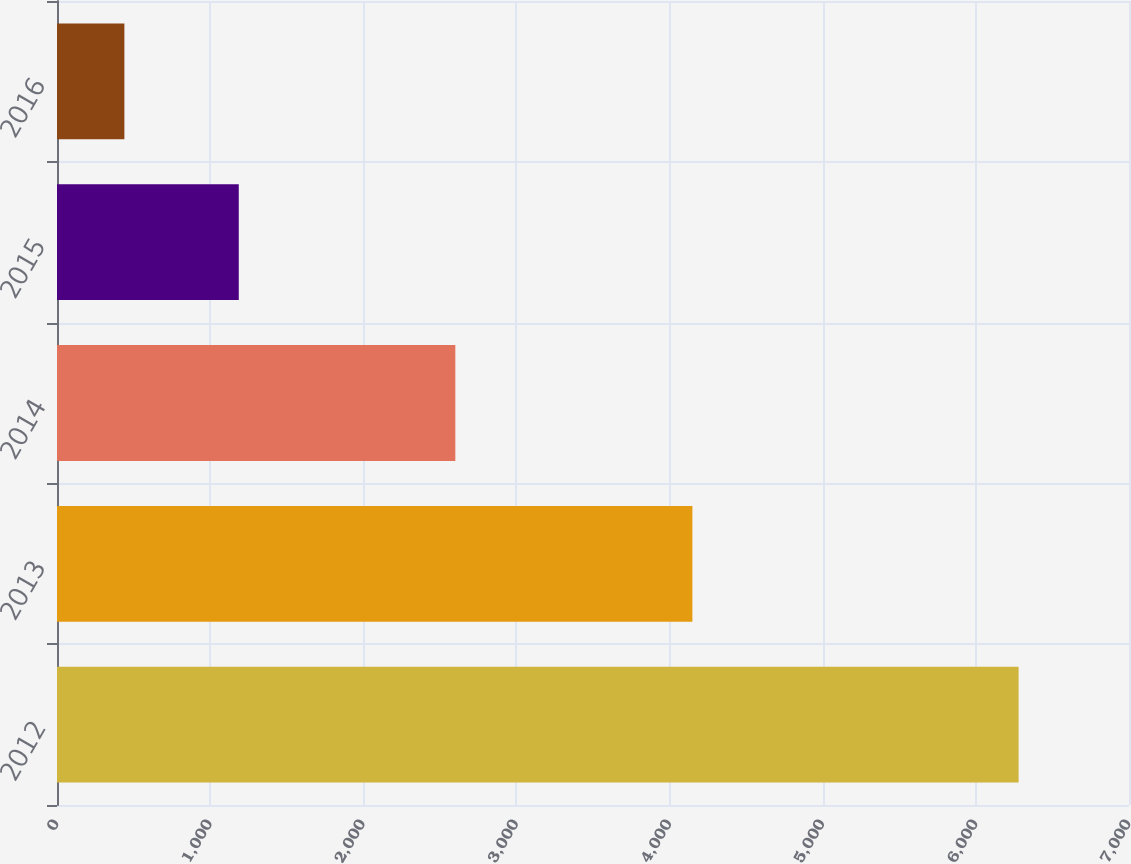Convert chart to OTSL. <chart><loc_0><loc_0><loc_500><loc_500><bar_chart><fcel>2012<fcel>2013<fcel>2014<fcel>2015<fcel>2016<nl><fcel>6279<fcel>4149<fcel>2601<fcel>1187<fcel>440<nl></chart> 